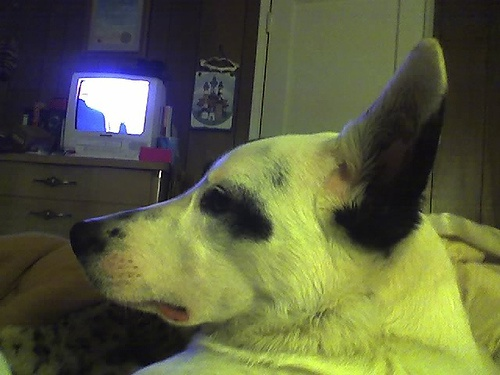Describe the objects in this image and their specific colors. I can see dog in black, olive, khaki, and darkgreen tones, tv in black, white, gray, and blue tones, and couch in black and darkgreen tones in this image. 